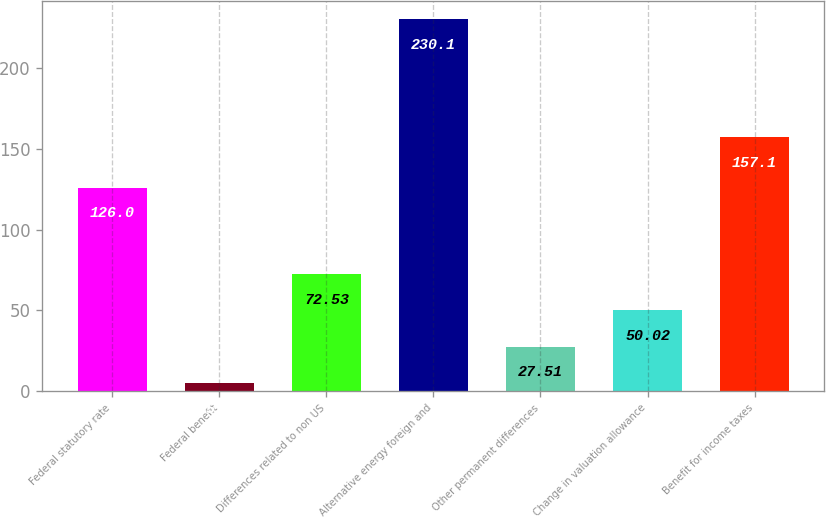Convert chart to OTSL. <chart><loc_0><loc_0><loc_500><loc_500><bar_chart><fcel>Federal statutory rate<fcel>Federal benefit<fcel>Differences related to non US<fcel>Alternative energy foreign and<fcel>Other permanent differences<fcel>Change in valuation allowance<fcel>Benefit for income taxes<nl><fcel>126<fcel>5<fcel>72.53<fcel>230.1<fcel>27.51<fcel>50.02<fcel>157.1<nl></chart> 